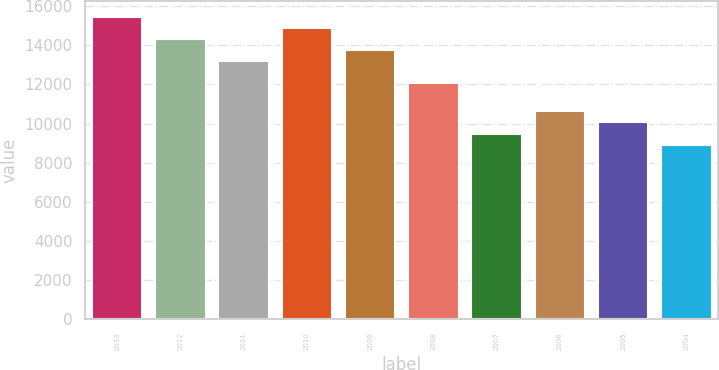<chart> <loc_0><loc_0><loc_500><loc_500><bar_chart><fcel>2013<fcel>2012<fcel>2011<fcel>2010<fcel>2009<fcel>2008<fcel>2007<fcel>2006<fcel>2005<fcel>2004<nl><fcel>15467<fcel>14334<fcel>13201<fcel>14900.5<fcel>13767.5<fcel>12077<fcel>9490.5<fcel>10623.5<fcel>10057<fcel>8924<nl></chart> 